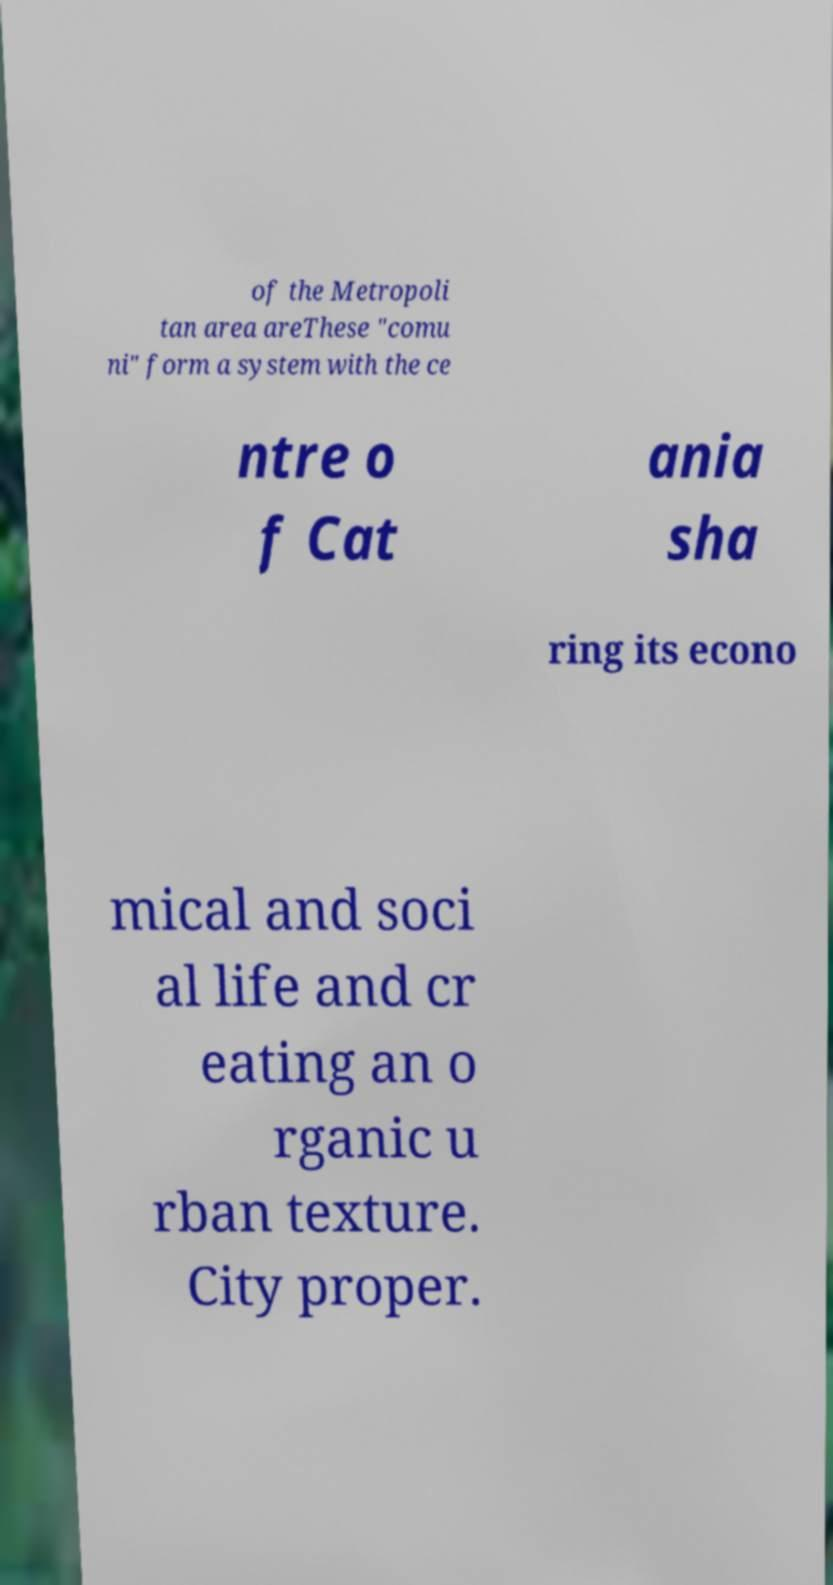Could you assist in decoding the text presented in this image and type it out clearly? of the Metropoli tan area areThese "comu ni" form a system with the ce ntre o f Cat ania sha ring its econo mical and soci al life and cr eating an o rganic u rban texture. City proper. 